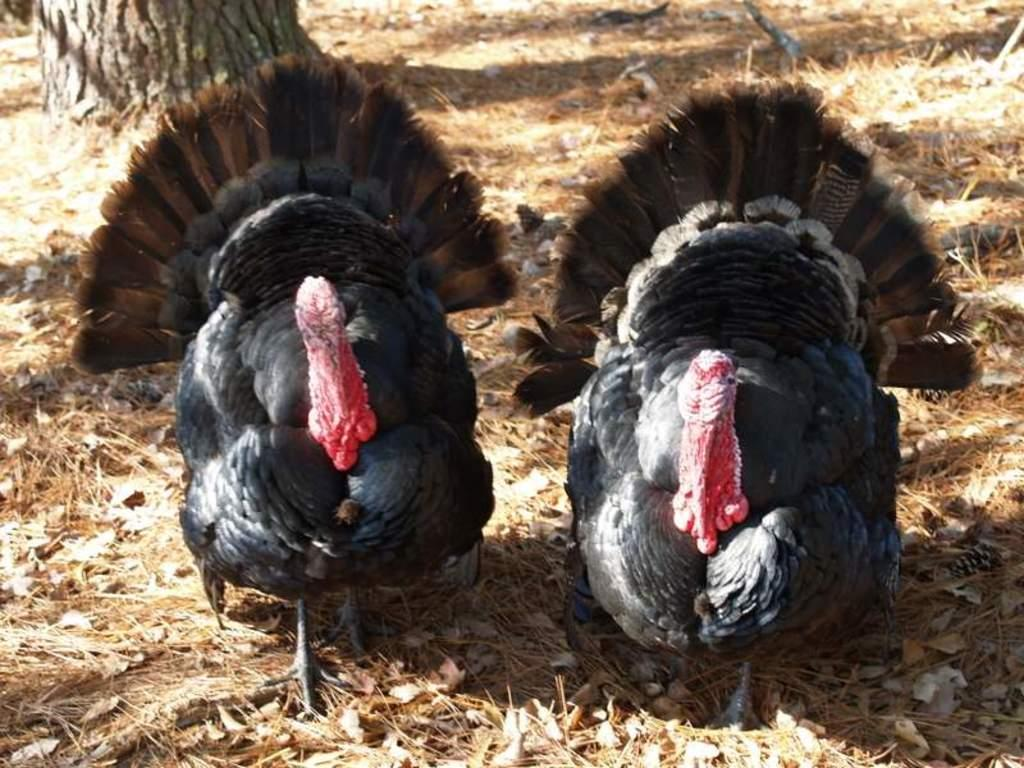How many birds are present in the image? There are two birds in the image. What colors are the birds in the image? The birds are in black and red color. What type of vegetation is visible in the image? There is dried grass in the image. What color is the dried grass in the image? The dried grass is in brown color. Can you see any dirt on the birds in the image? There is no dirt visible on the birds in the image. What type of glove is being used by the birds in the image? There are no gloves present in the image, as it features birds and dried grass. Is there any salt visible on the dried grass in the image? There is no salt visible on the dried grass in the image. 